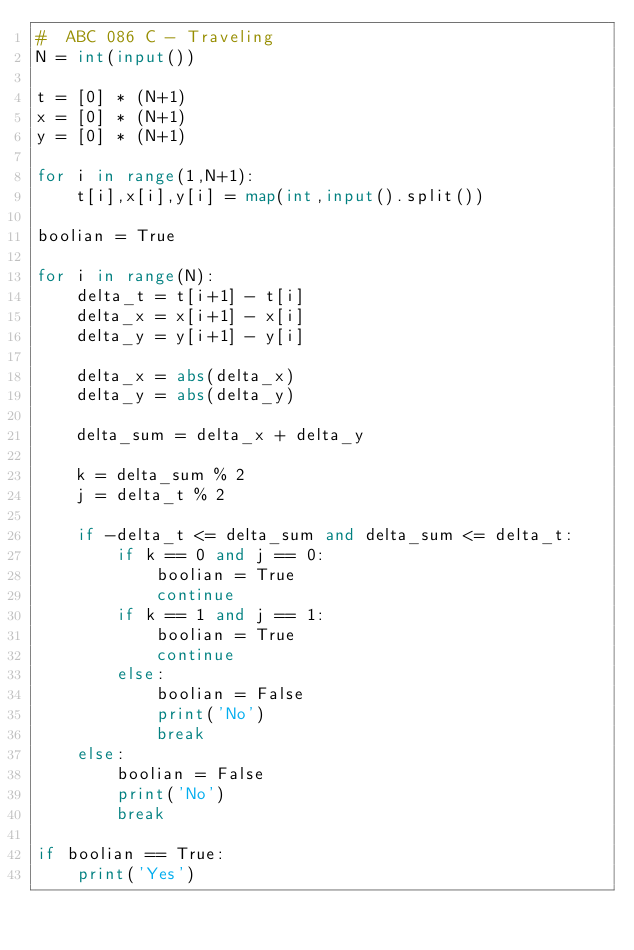<code> <loc_0><loc_0><loc_500><loc_500><_Python_>#  ABC 086 C - Traveling
N = int(input())

t = [0] * (N+1)
x = [0] * (N+1)
y = [0] * (N+1)

for i in range(1,N+1):
    t[i],x[i],y[i] = map(int,input().split())

boolian = True    
        
for i in range(N):
    delta_t = t[i+1] - t[i]
    delta_x = x[i+1] - x[i]
    delta_y = y[i+1] - y[i]
    
    delta_x = abs(delta_x)
    delta_y = abs(delta_y)
    
    delta_sum = delta_x + delta_y
    
    k = delta_sum % 2 
    j = delta_t % 2

    if -delta_t <= delta_sum and delta_sum <= delta_t:
        if k == 0 and j == 0:
            boolian = True
            continue
        if k == 1 and j == 1:
            boolian = True
            continue
        else:
            boolian = False
            print('No')
            break
    else:
        boolian = False
        print('No')
        break

if boolian == True:
    print('Yes')</code> 